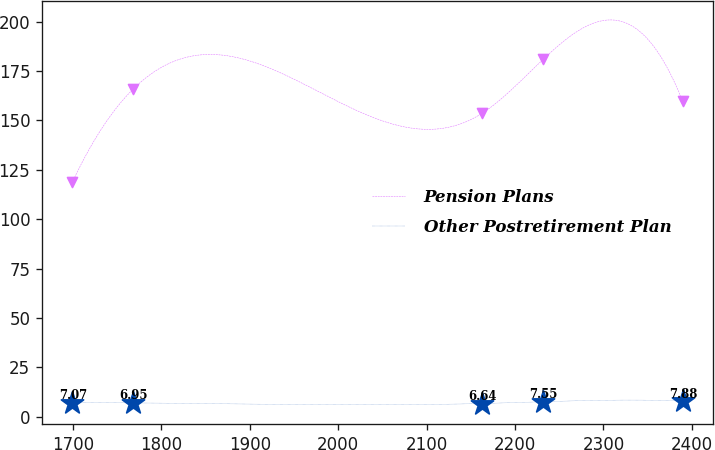Convert chart. <chart><loc_0><loc_0><loc_500><loc_500><line_chart><ecel><fcel>Pension Plans<fcel>Other Postretirement Plan<nl><fcel>1699.49<fcel>118.85<fcel>7.07<nl><fcel>1768.5<fcel>166.04<fcel>6.95<nl><fcel>2162.81<fcel>153.62<fcel>6.64<nl><fcel>2231.82<fcel>180.94<fcel>7.55<nl><fcel>2389.59<fcel>159.83<fcel>7.88<nl></chart> 